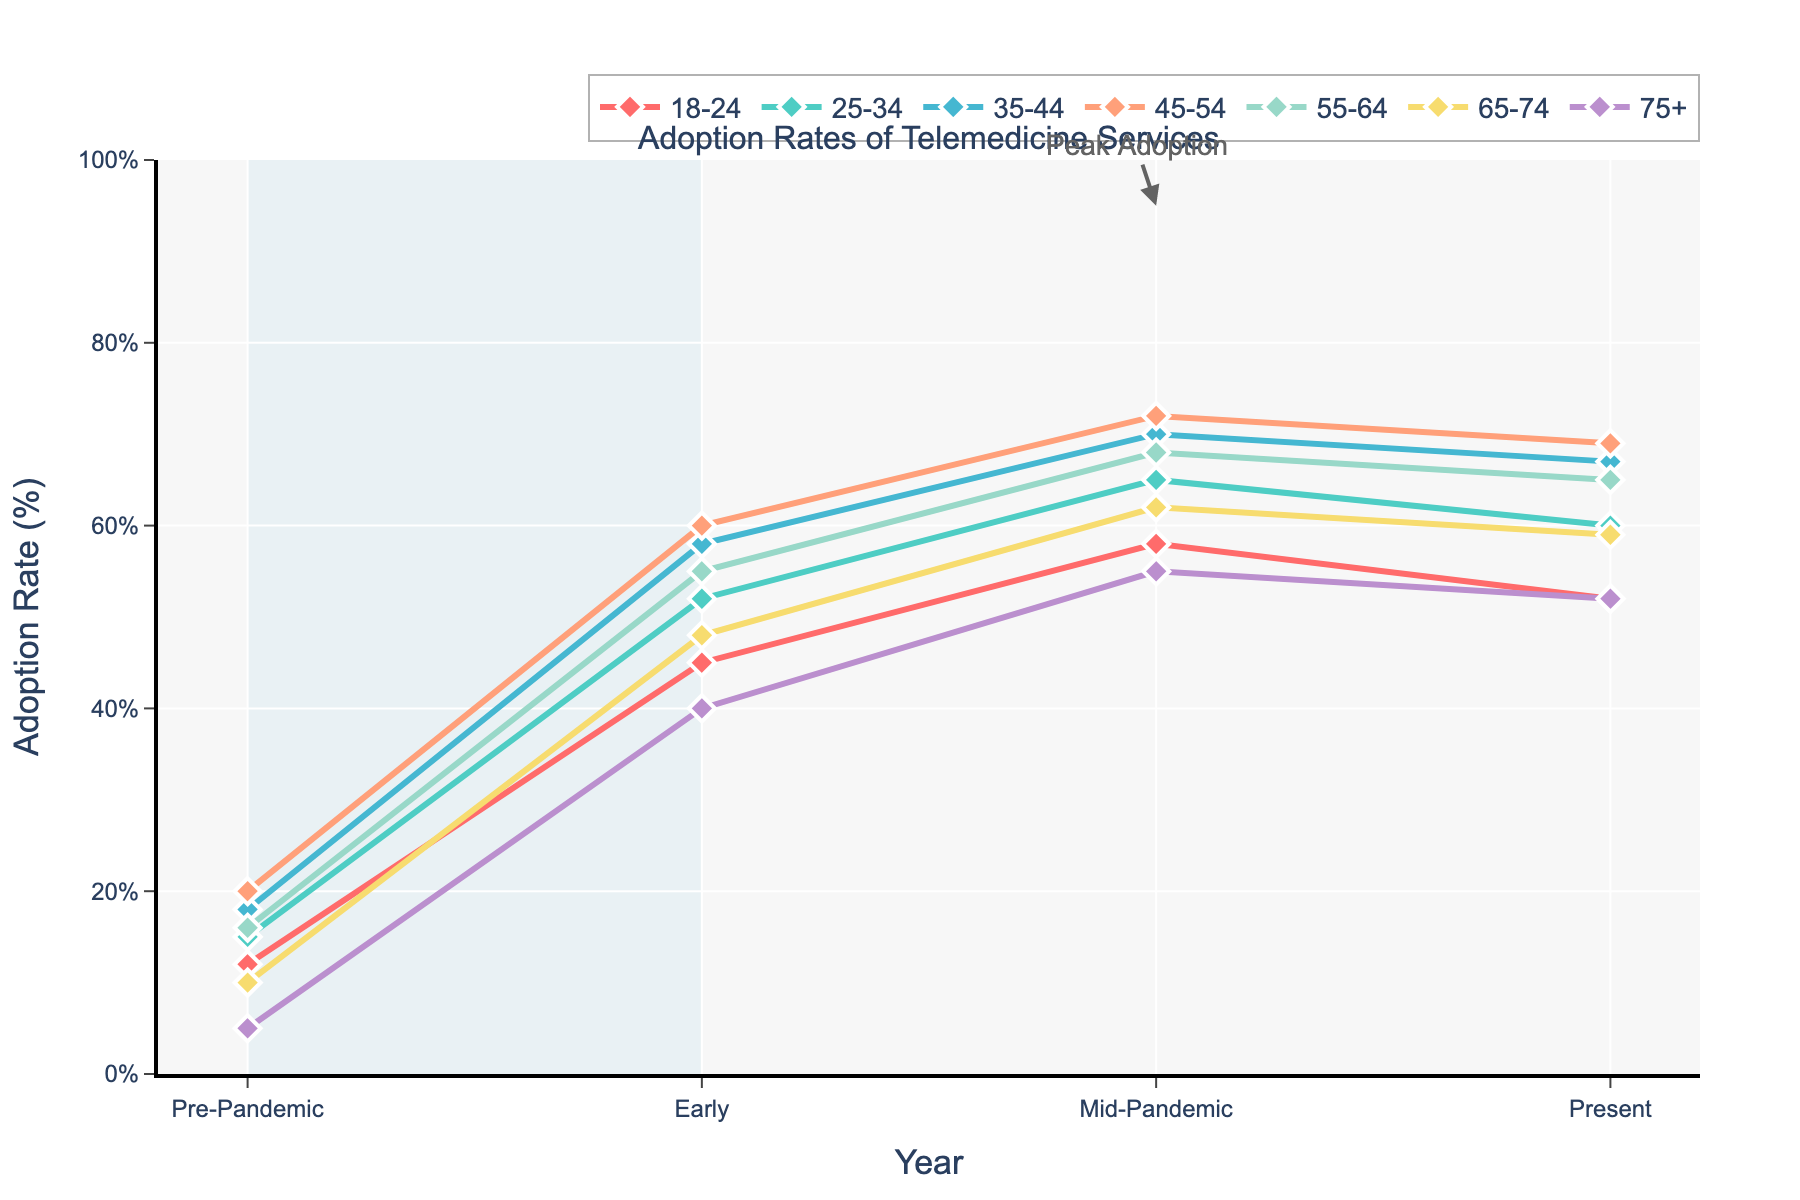What is the overall trend in telemedicine adoption rates from pre-pandemic to present day for the 18-24 age group? Observing the line for the 18-24 age group, the adoption rate increased significantly from 12% in pre-pandemic to 45% in early pandemic, continued to rise to 58% in mid-pandemic, and then slightly decreased to 52% in present day.
Answer: Increased Which age group experienced the highest adoption rate during mid-pandemic (2021)? By looking at the peak points of all the lines in the mid-pandemic (2021), the 45-54 age group shows the highest adoption rate of 72%.
Answer: 45-54 Compare the adoption rate difference between early pandemic (2020) and present day (2023) for the 65-74 age group. The adoption rate for the 65-74 age group was 48% in early pandemic and 59% in present day. The difference is 59% - 48% = 11%.
Answer: 11% Which age group shows a decline in adoption rates from mid-pandemic (2021) to present day (2023)? Observing the slopes of the lines from mid-pandemic to present day, the 18-24, 25-34, and 75+ age groups show a decline.
Answer: 18-24, 25-34, 75+ What is the percentage point change in adoption rates for the 75+ age group from pre-pandemic to early pandemic? The adoption rate for the 75+ age group increased from 5% in pre-pandemic to 40% in early pandemic. The change is 40% - 5% = 35%.
Answer: 35% Among all age groups, identify which two experienced the least change in adoption rates from early pandemic (2020) to mid-pandemic (2021). Observing the changes in heights of the plotted points from early pandemic to mid-pandemic for each age group, the 18-24 age group increased from 45% to 58% (a change of 13%), and the 75+ age group from 40% to 55% (a change of 15%). These changes are the smallest among all groups.
Answer: 18-24 and 75+ Calculate the average adoption rate for the 35-44 age group across all years represented. The adoption rates for the 35-44 age group over the years are 18%, 58%, 70%, and 67%. The average is calculated as (18 + 58 + 70 + 67) / 4 = 213 / 4 = 53.25%.
Answer: 53.25% Which age group had the lowest adoption rate pre-pandemic, and what was the rate? By looking at the pre-pandemic values, the 75+ age group had the lowest adoption rate of 5%.
Answer: 75+, 5% What is the trend for the 55-64 age group from pre-pandemic to present day? For the 55-64 age group, the adoption rate started at 16% pre-pandemic, increased to 55% during the early pandemic, further rose to 68% mid-pandemic, and then slightly declined to 65% in present day. The overall trend shows a significant increase with a minor reduction towards the end.
Answer: Increase with slight decrease 